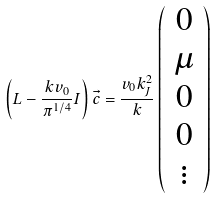Convert formula to latex. <formula><loc_0><loc_0><loc_500><loc_500>\left ( L - \frac { k v _ { 0 } } { \pi ^ { 1 / 4 } } { I } \right ) \vec { c } = \frac { v _ { 0 } k _ { J } ^ { 2 } } { k } \left ( \begin{array} { c } 0 \\ \mu \\ 0 \\ 0 \\ \vdots \end{array} \right )</formula> 